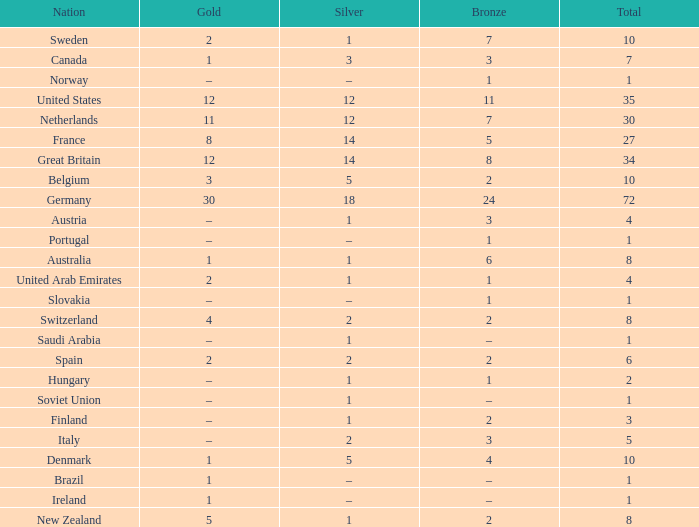What is Gold, when Bronze is 11? 12.0. 